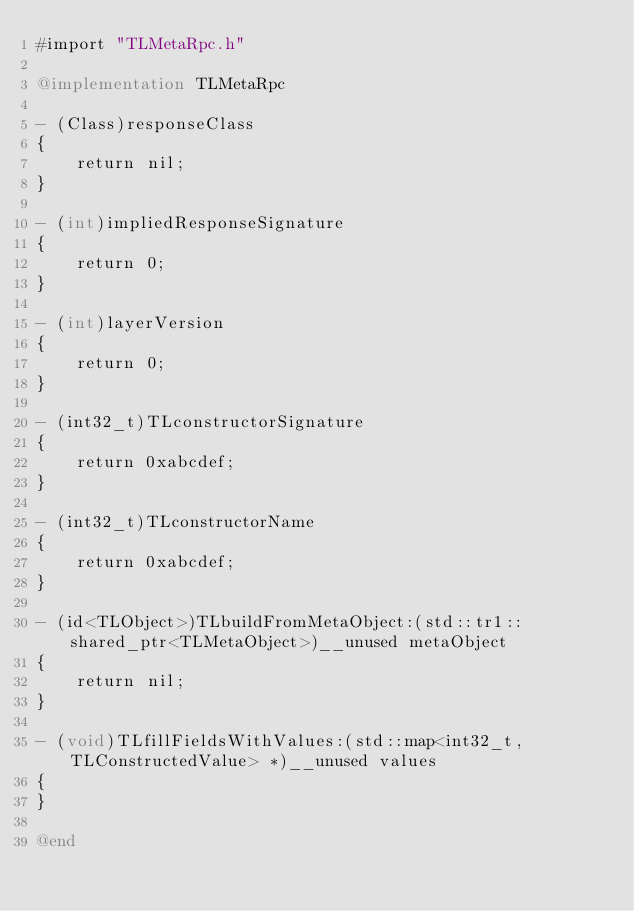Convert code to text. <code><loc_0><loc_0><loc_500><loc_500><_ObjectiveC_>#import "TLMetaRpc.h"

@implementation TLMetaRpc

- (Class)responseClass
{
    return nil;
}

- (int)impliedResponseSignature
{
    return 0;
}

- (int)layerVersion
{
    return 0;
}

- (int32_t)TLconstructorSignature
{
    return 0xabcdef;
}

- (int32_t)TLconstructorName
{
    return 0xabcdef;
}

- (id<TLObject>)TLbuildFromMetaObject:(std::tr1::shared_ptr<TLMetaObject>)__unused metaObject
{
    return nil;
}

- (void)TLfillFieldsWithValues:(std::map<int32_t, TLConstructedValue> *)__unused values
{
}

@end</code> 